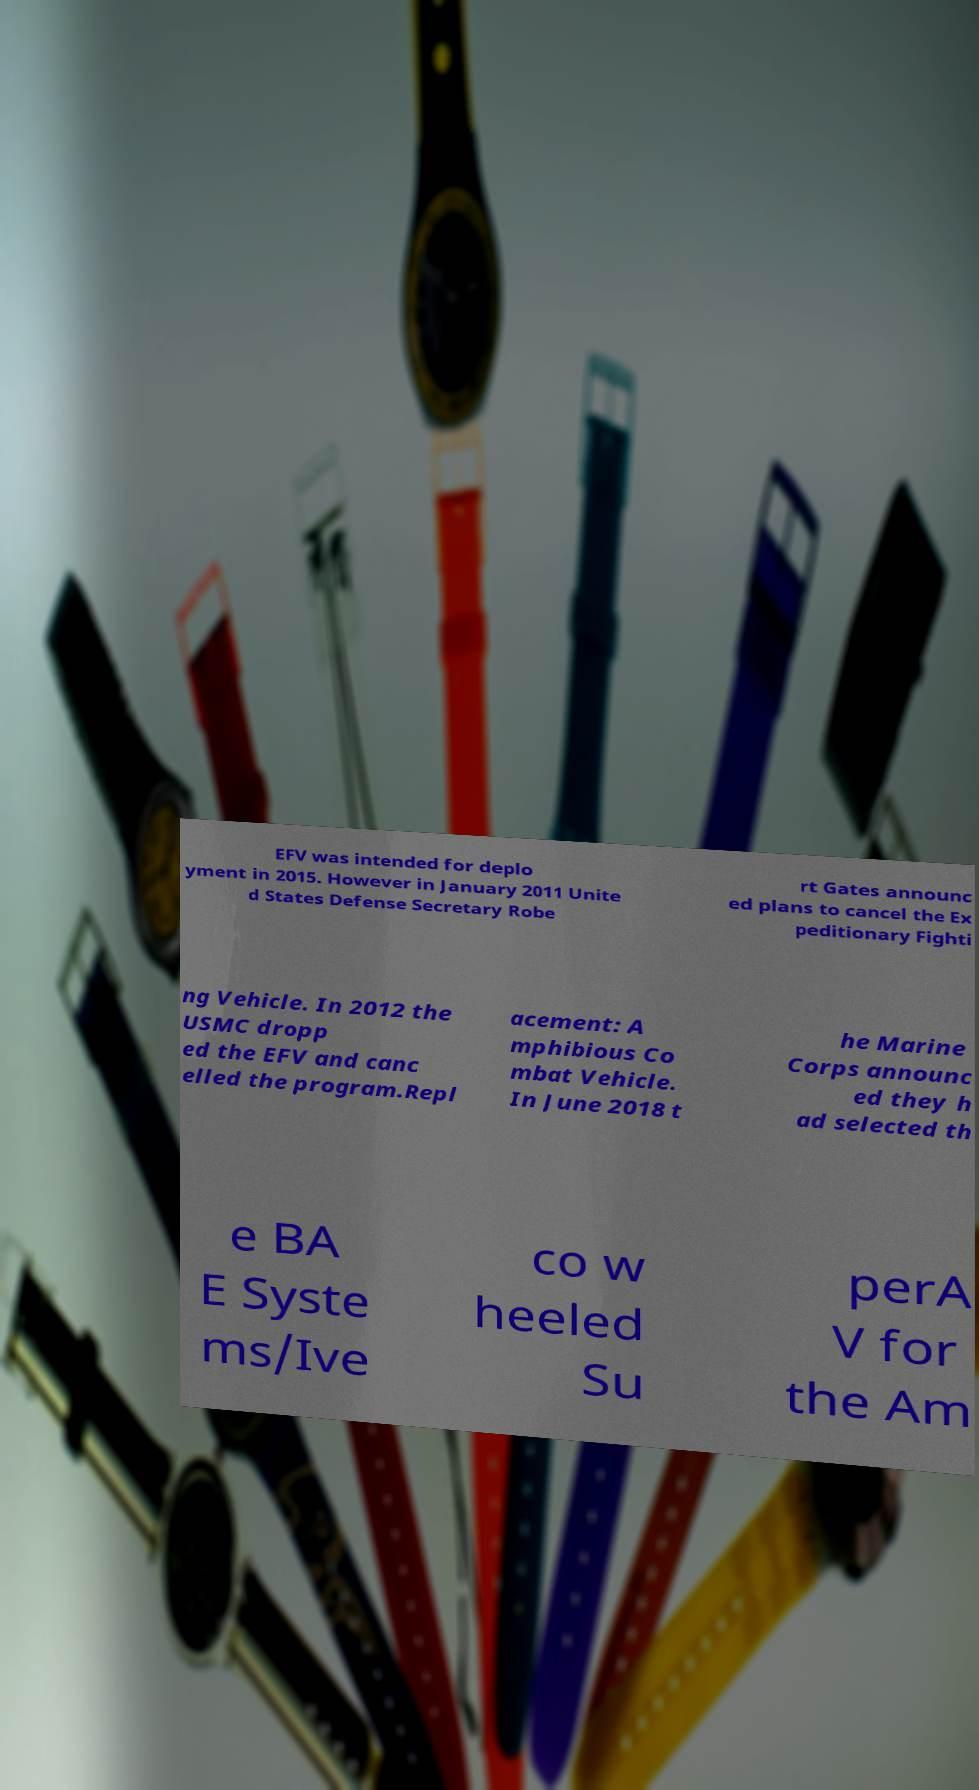Could you extract and type out the text from this image? EFV was intended for deplo yment in 2015. However in January 2011 Unite d States Defense Secretary Robe rt Gates announc ed plans to cancel the Ex peditionary Fighti ng Vehicle. In 2012 the USMC dropp ed the EFV and canc elled the program.Repl acement: A mphibious Co mbat Vehicle. In June 2018 t he Marine Corps announc ed they h ad selected th e BA E Syste ms/Ive co w heeled Su perA V for the Am 